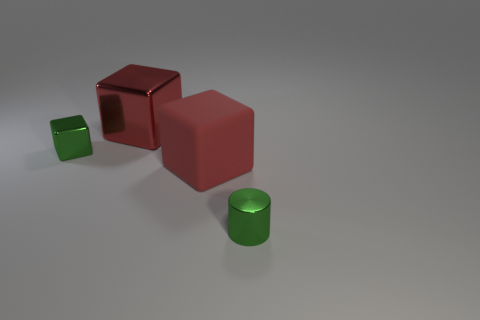Are there fewer green cubes than brown metal cubes?
Provide a short and direct response. No. There is a red shiny object; what shape is it?
Give a very brief answer. Cube. Is the color of the tiny shiny object to the left of the large metal cube the same as the cylinder?
Your response must be concise. Yes. What shape is the thing that is both behind the small cylinder and to the right of the big red metal block?
Your answer should be compact. Cube. The small thing behind the tiny green cylinder is what color?
Make the answer very short. Green. Is there anything else of the same color as the metallic cylinder?
Give a very brief answer. Yes. Is the red metal cube the same size as the green metallic cylinder?
Provide a succinct answer. No. How big is the metallic object that is in front of the red shiny block and behind the small green shiny cylinder?
Provide a short and direct response. Small. How many other small green cylinders have the same material as the tiny green cylinder?
Give a very brief answer. 0. The small shiny object that is the same color as the cylinder is what shape?
Offer a very short reply. Cube. 